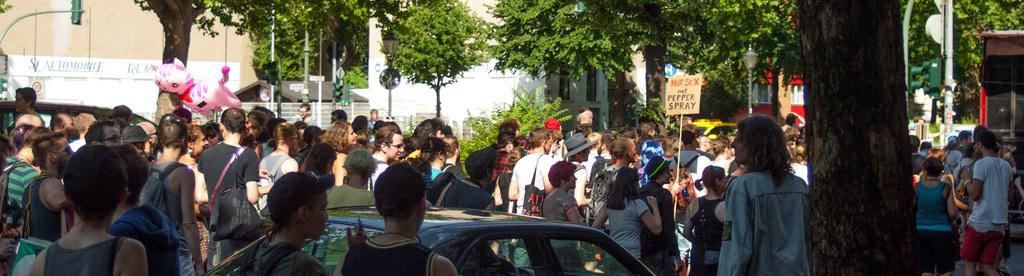What can be seen at the bottom of the image? At the bottom of the image, there are persons in different color dresses, a vehicle, and a tree. What is visible in the background of the image? In the background of the image, there are trees, plants, buildings, and poles. Can you hear the bells ringing in the image? There are no bells present in the image, so it is not possible to hear them ringing. Is the brother of the person in the image also visible? The facts provided do not mention any specific person or their relatives, so it is not possible to determine if the brother is visible in the image. 